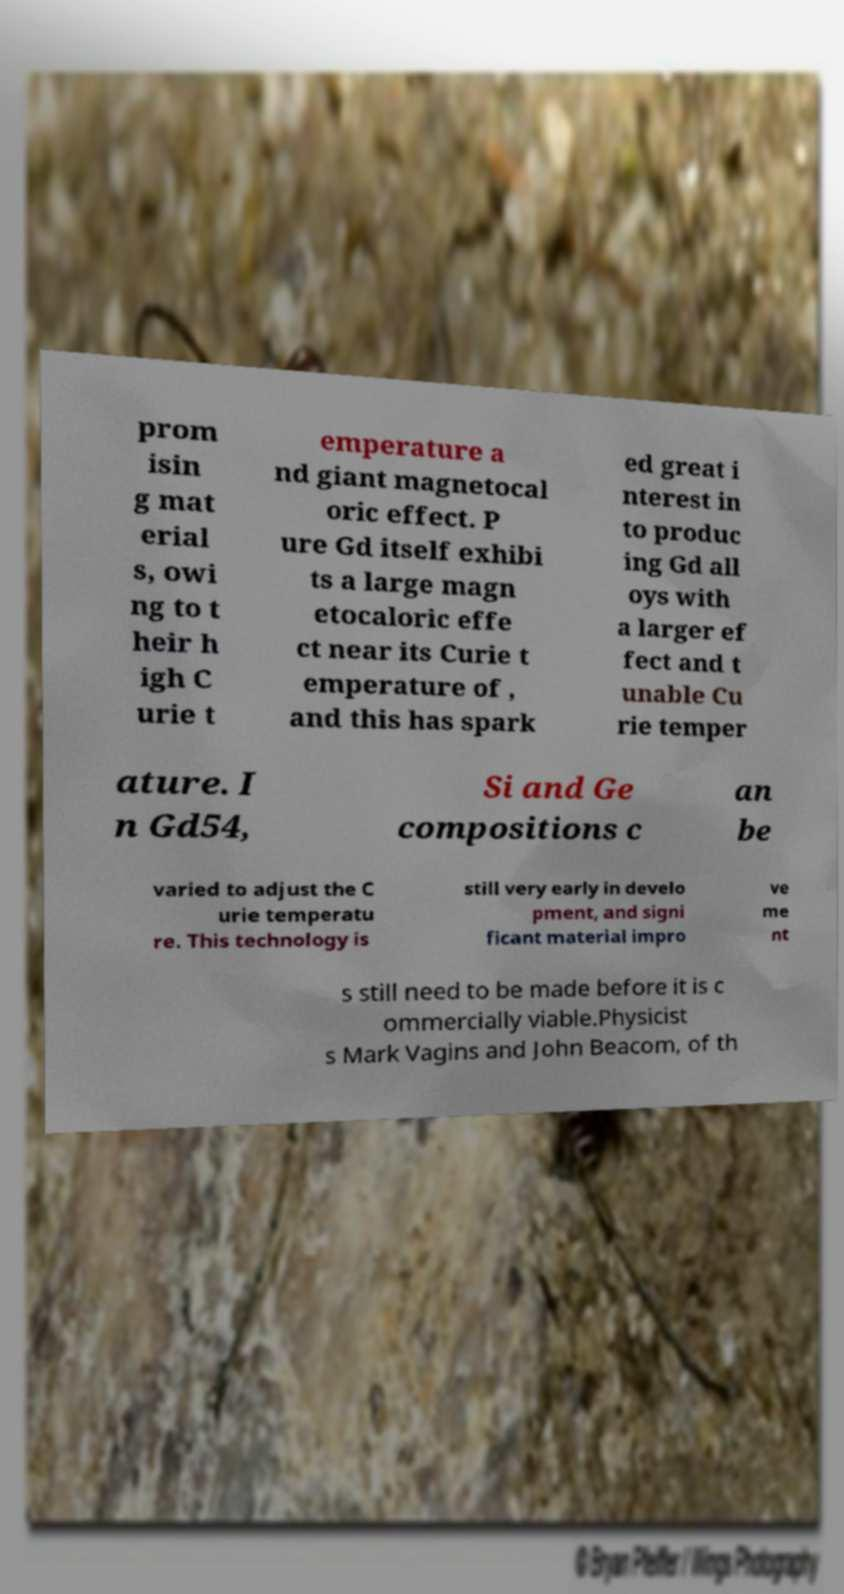There's text embedded in this image that I need extracted. Can you transcribe it verbatim? prom isin g mat erial s, owi ng to t heir h igh C urie t emperature a nd giant magnetocal oric effect. P ure Gd itself exhibi ts a large magn etocaloric effe ct near its Curie t emperature of , and this has spark ed great i nterest in to produc ing Gd all oys with a larger ef fect and t unable Cu rie temper ature. I n Gd54, Si and Ge compositions c an be varied to adjust the C urie temperatu re. This technology is still very early in develo pment, and signi ficant material impro ve me nt s still need to be made before it is c ommercially viable.Physicist s Mark Vagins and John Beacom, of th 